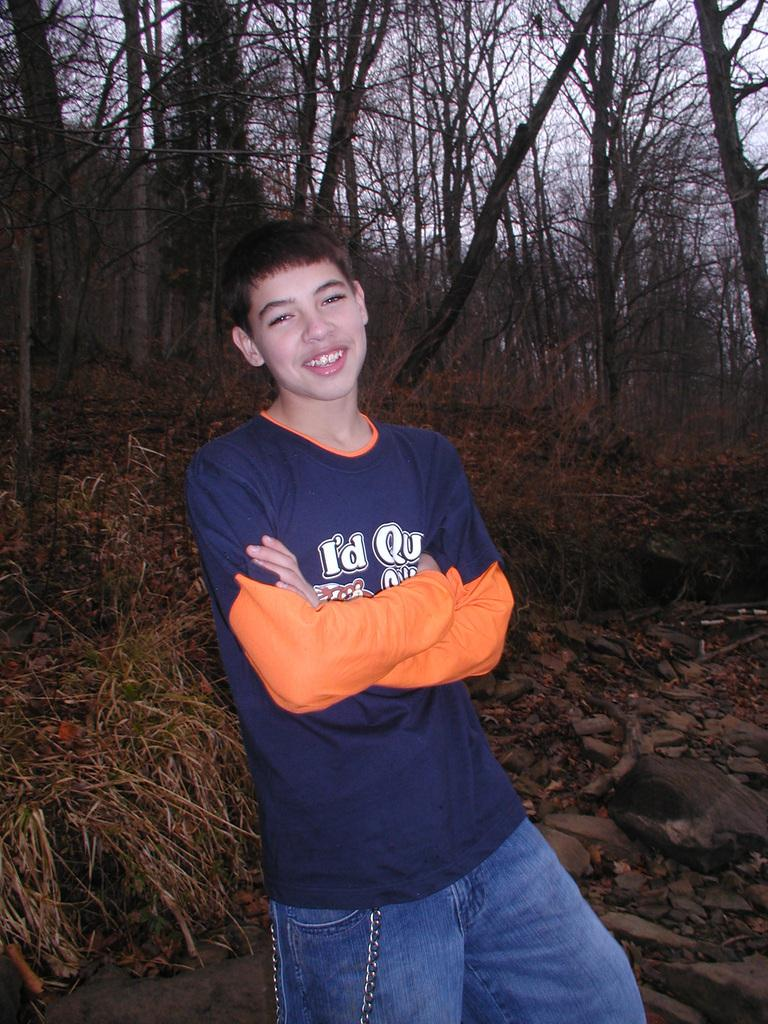<image>
Present a compact description of the photo's key features. You can see I'd Qu on the boys blue and orange shirt. 